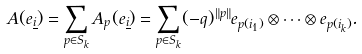<formula> <loc_0><loc_0><loc_500><loc_500>A ( e _ { \underline { i } } ) = \sum _ { p \in S _ { k } } A _ { p } ( e _ { \underline { i } } ) = \sum _ { p \in S _ { k } } ( - q ) ^ { \| p \| } e _ { p ( i _ { 1 } ) } \otimes \cdots \otimes e _ { p ( i _ { k } ) } .</formula> 